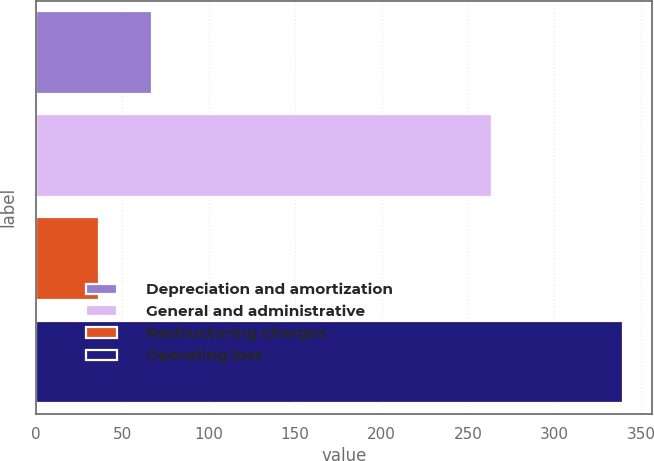Convert chart to OTSL. <chart><loc_0><loc_0><loc_500><loc_500><bar_chart><fcel>Depreciation and amortization<fcel>General and administrative<fcel>Restructuring charges<fcel>Operating loss<nl><fcel>67.07<fcel>263.9<fcel>36.8<fcel>339.5<nl></chart> 